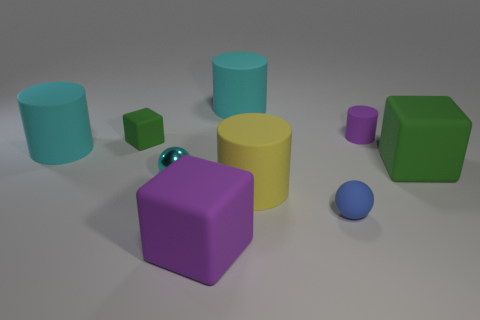How many gray objects have the same size as the blue thing?
Ensure brevity in your answer.  0. Is the size of the cyan rubber object that is right of the tiny green rubber thing the same as the green matte block to the left of the yellow matte cylinder?
Your answer should be compact. No. There is a small object that is in front of the small block and behind the blue matte thing; what is its shape?
Provide a succinct answer. Sphere. Is there a tiny matte thing of the same color as the matte ball?
Your answer should be very brief. No. Are there any cyan metallic things?
Your answer should be compact. Yes. There is a tiny matte thing that is in front of the large yellow cylinder; what is its color?
Keep it short and to the point. Blue. There is a metallic thing; does it have the same size as the cyan rubber cylinder that is behind the tiny purple object?
Your response must be concise. No. What size is the matte block that is to the left of the tiny purple rubber cylinder and behind the matte ball?
Provide a short and direct response. Small. Are there any large yellow spheres that have the same material as the big yellow cylinder?
Offer a terse response. No. The small shiny object is what shape?
Offer a very short reply. Sphere. 